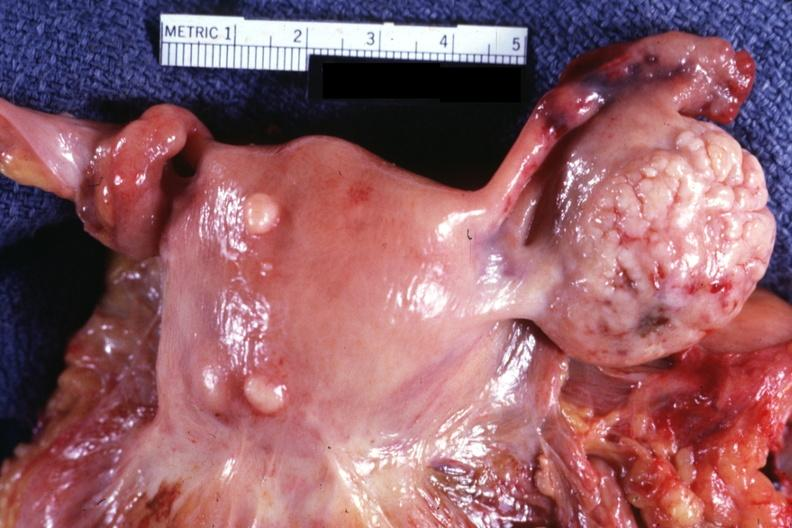s female reproductive present?
Answer the question using a single word or phrase. Yes 